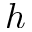<formula> <loc_0><loc_0><loc_500><loc_500>h</formula> 